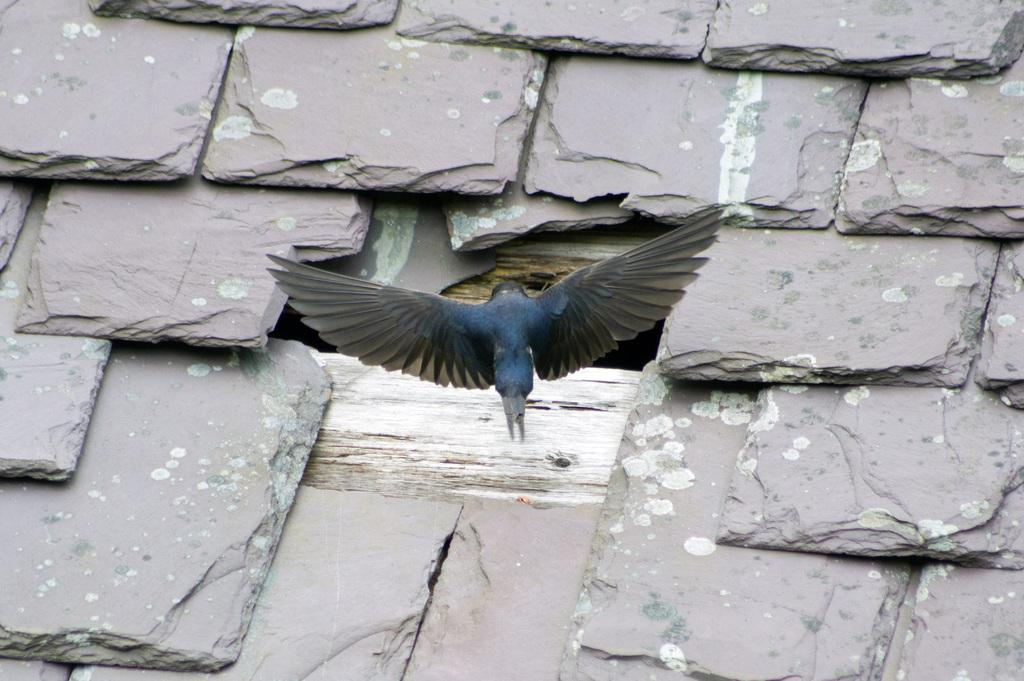What is the main subject in the center of the image? There is a bird in the center of the image. What can be seen in the background of the image? There are stones visible in the background of the image. What type of maid is present in the image? There is no maid present in the image; it features a bird and stones in the background. What class of animal is the bird in the image? The bird in the image is not classified by class; it is simply a bird. 